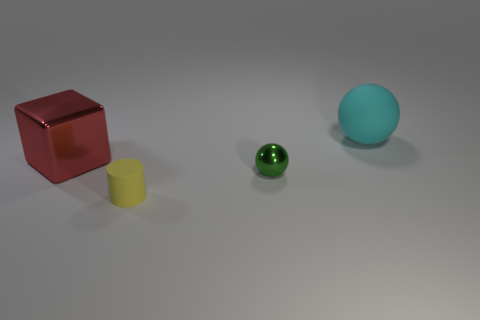Can you describe the lighting and shadows visible in the scene? The lighting in the scene appears to be coming from above, casting soft shadows directly below the objects. This suggests an indoor setting with diffused lighting, such as from an overhead source or ambient lighting in a room. 